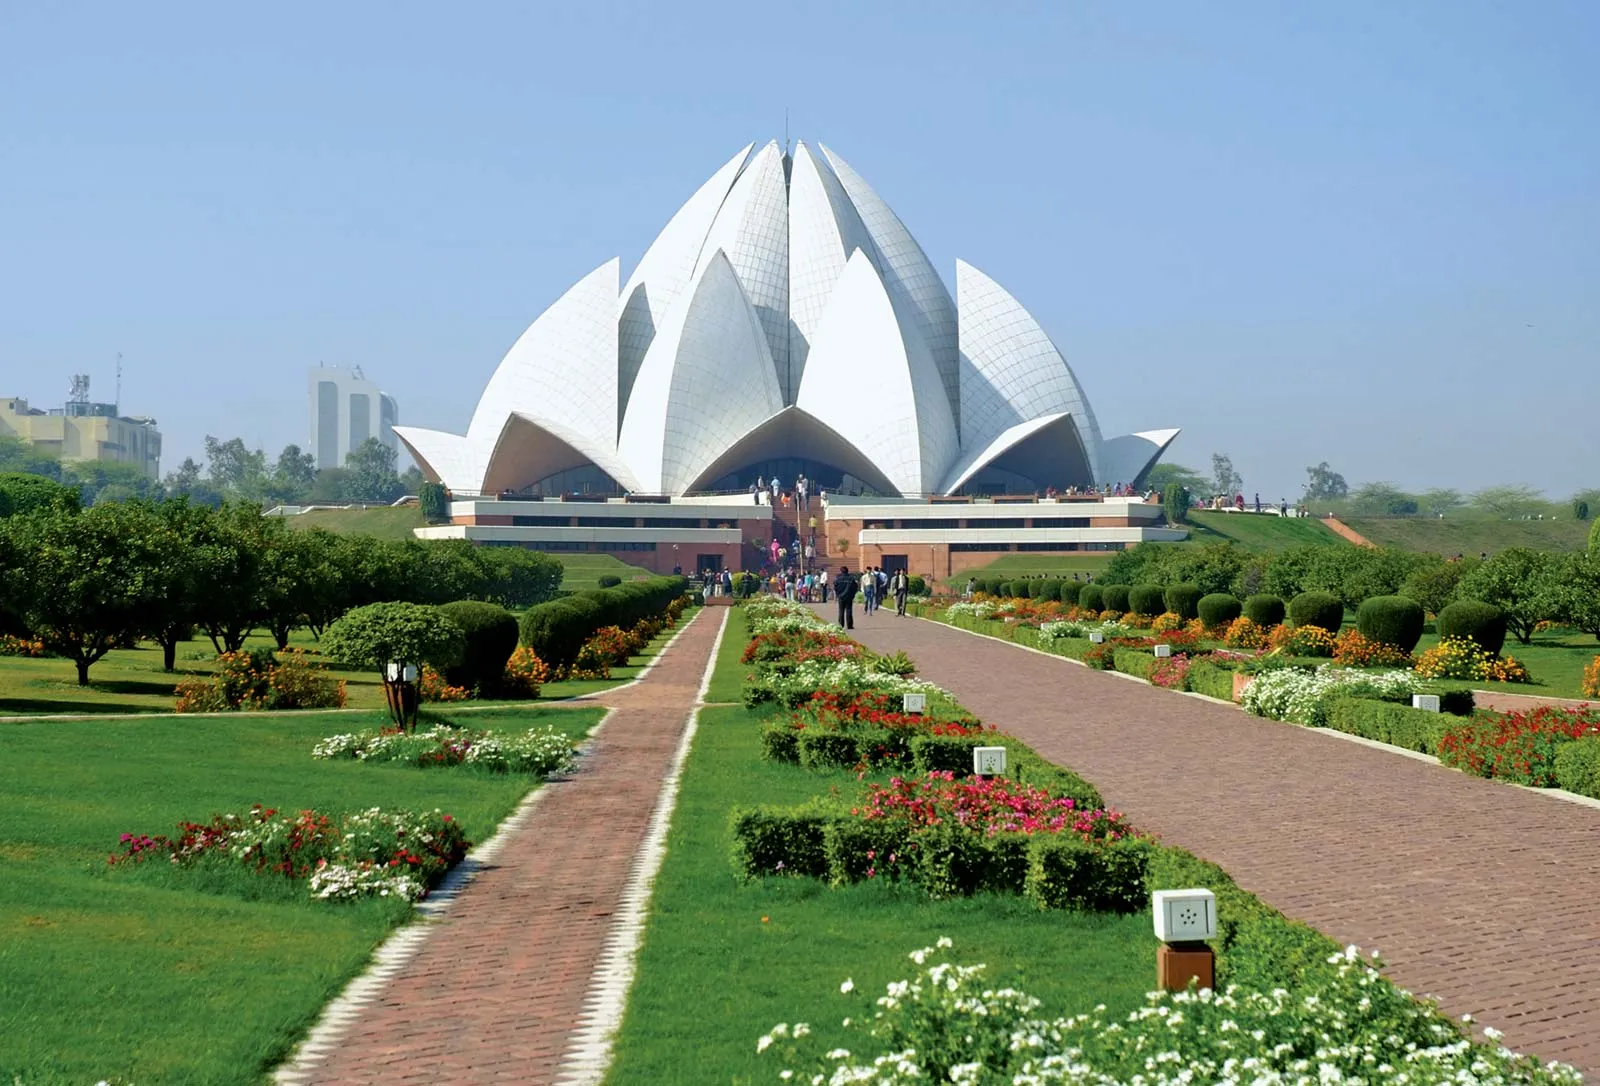Can you tell me more about the architectural design of Lotus Temple? Certainly! The Lotus Temple is an architectural marvel designed by Iranian architect Fariborz Sahba. It is shaped to resemble a lotus flower, a symbol of purity and peace in several cultures. The structure consists of 27 free-standing marble petals grouped into clusters of three to form nine sides. Nine doors open onto a central hall capable of holding up to 2,500 people. The design integrates natural light beautifully, which filters through the petals and bathes the interior in a soft, ethereal glow. 